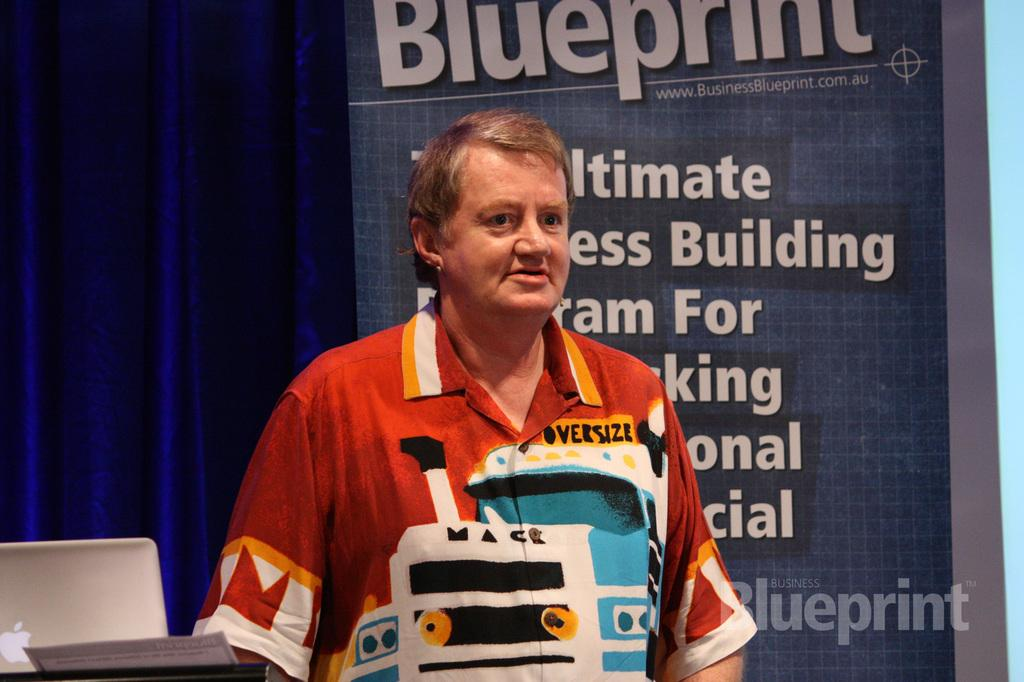Provide a one-sentence caption for the provided image. A man in front of a poster with the headline Blueprint. 